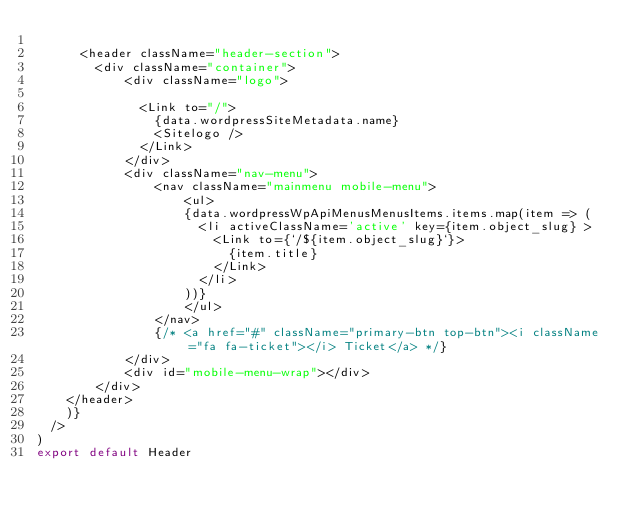<code> <loc_0><loc_0><loc_500><loc_500><_JavaScript_>
      <header className="header-section">
        <div className="container">
            <div className="logo">
            
              <Link to="/">
                {data.wordpressSiteMetadata.name}
                <Sitelogo />
              </Link>
            </div>
            <div className="nav-menu">
                <nav className="mainmenu mobile-menu">
                    <ul>
                    {data.wordpressWpApiMenusMenusItems.items.map(item => (
                      <li activeClassName='active' key={item.object_slug} >
                        <Link to={`/${item.object_slug}`}>
                          {item.title}
                        </Link>
                      </li>
                    ))}
                    </ul>
                </nav>
                {/* <a href="#" className="primary-btn top-btn"><i className="fa fa-ticket"></i> Ticket</a> */}
            </div>
            <div id="mobile-menu-wrap"></div>
        </div>
    </header>
    )}
  />
)
export default Header</code> 